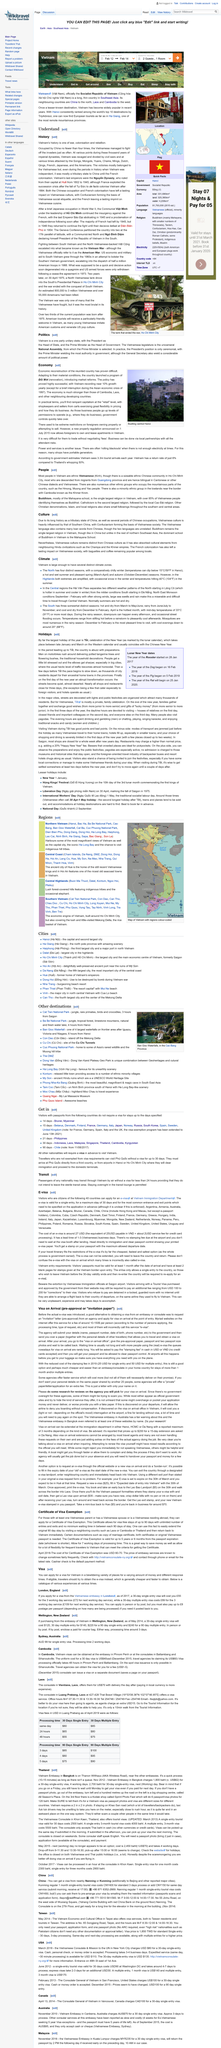Specify some key components in this picture. Vietnam is divided into three distinct climate zones: the North, the Central, and the South. Foreigners are permitted to own and lease apartments in Vietnam, as announced in a new property regulation on July 1st, 2015. The e-visa cannot be extended. According to government estimates, Vietnam welcomes approximately 3.3 million tourists annually. The return rate of tourists to Vietnam is approximately 6%. 